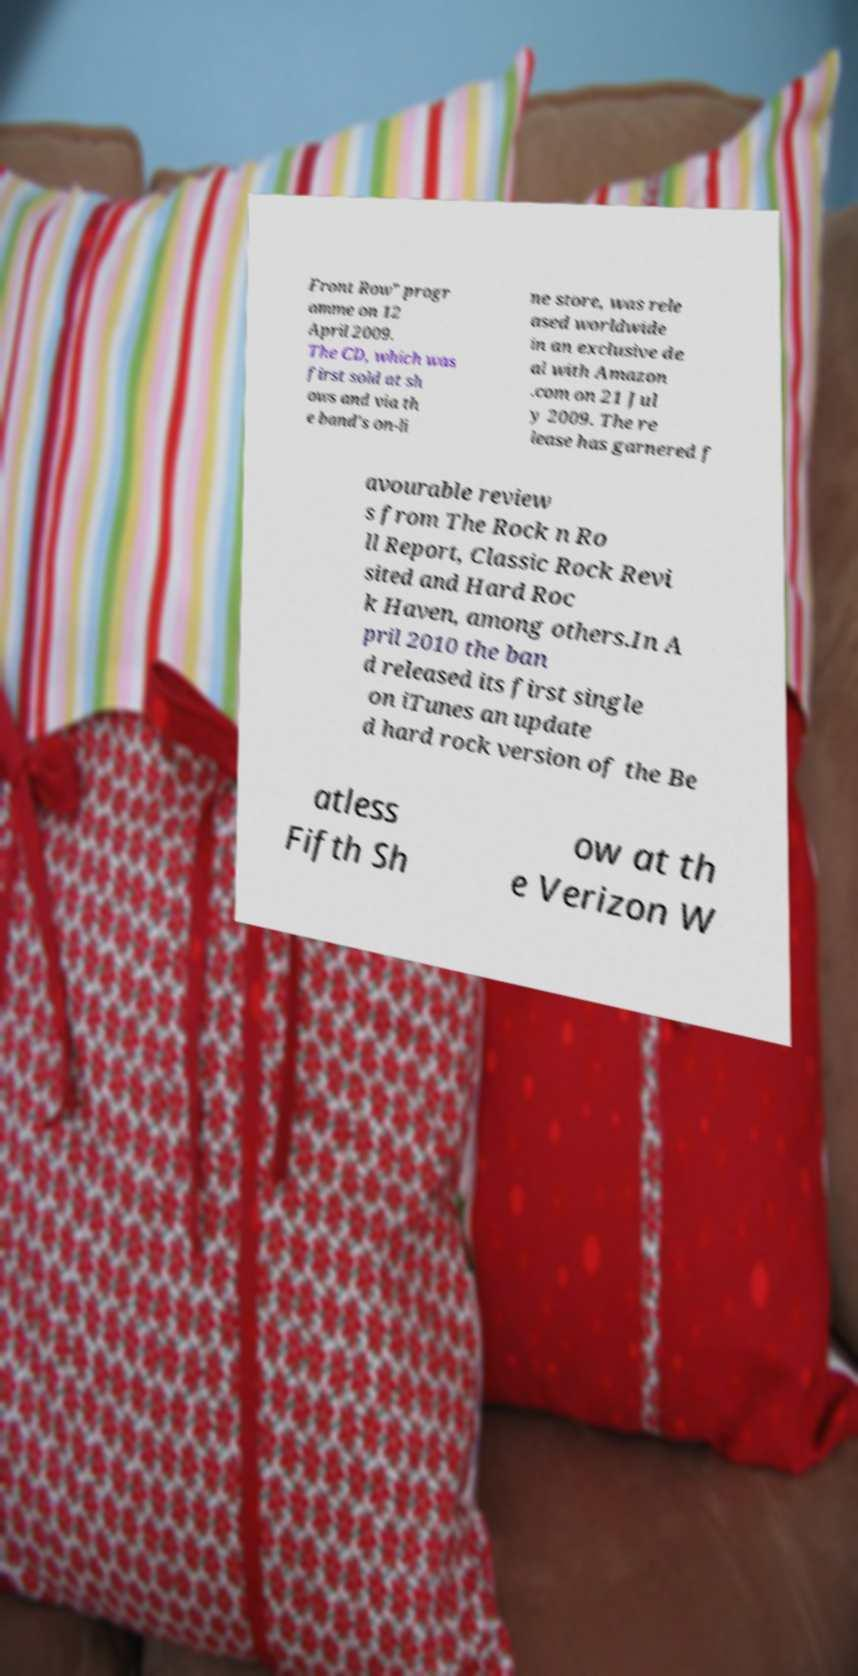Can you read and provide the text displayed in the image?This photo seems to have some interesting text. Can you extract and type it out for me? Front Row" progr amme on 12 April 2009. The CD, which was first sold at sh ows and via th e band's on-li ne store, was rele ased worldwide in an exclusive de al with Amazon .com on 21 Jul y 2009. The re lease has garnered f avourable review s from The Rock n Ro ll Report, Classic Rock Revi sited and Hard Roc k Haven, among others.In A pril 2010 the ban d released its first single on iTunes an update d hard rock version of the Be atless Fifth Sh ow at th e Verizon W 